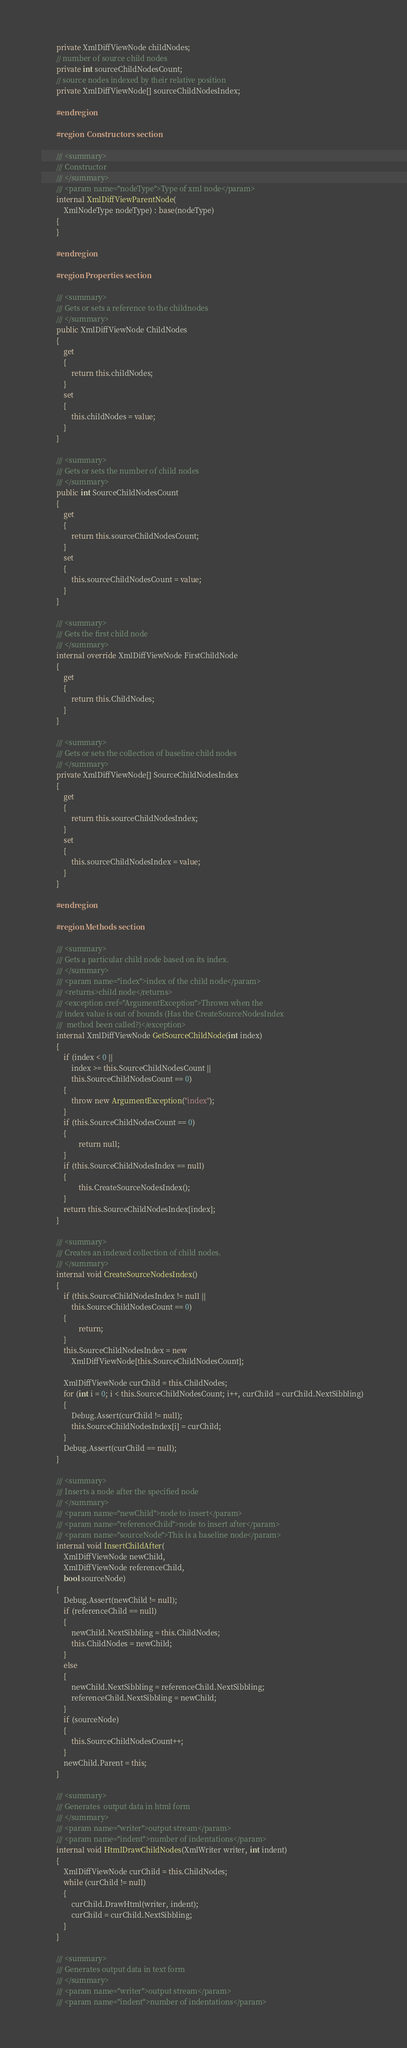<code> <loc_0><loc_0><loc_500><loc_500><_C#_>        private XmlDiffViewNode childNodes;
        // number of source child nodes
        private int sourceChildNodesCount;
        // source nodes indexed by their relative position
        private XmlDiffViewNode[] sourceChildNodesIndex;
        
        #endregion
        
        #region  Constructors section

        /// <summary>
        /// Constructor
        /// </summary>
        /// <param name="nodeType">Type of xml node</param>
        internal XmlDiffViewParentNode(
            XmlNodeType nodeType) : base(nodeType) 
        {
        }
        
        #endregion

        #region Properties section

        /// <summary>
        /// Gets or sets a reference to the childnodes
        /// </summary>
        public XmlDiffViewNode ChildNodes
        {
            get
            {
                return this.childNodes;
            }
            set
            {
                this.childNodes = value;
            }
        }

        /// <summary>
        /// Gets or sets the number of child nodes
        /// </summary>
        public int SourceChildNodesCount
        {
            get
            {
                return this.sourceChildNodesCount;
            }
            set
            {
                this.sourceChildNodesCount = value;
            }
        }

        /// <summary>
        /// Gets the first child node
        /// </summary>
        internal override XmlDiffViewNode FirstChildNode
        { 
            get 
            { 
                return this.ChildNodes; 
            } 
        }

        /// <summary>
        /// Gets or sets the collection of baseline child nodes
        /// </summary>
        private XmlDiffViewNode[] SourceChildNodesIndex
        {
            get
            {
                return this.sourceChildNodesIndex;
            }
            set
            {
                this.sourceChildNodesIndex = value;
            }
        }

        #endregion
        
        #region Methods section

        /// <summary>
        /// Gets a particular child node based on its index.
        /// </summary>
        /// <param name="index">index of the child node</param>
        /// <returns>child node</returns>
        /// <exception cref="ArgumentException">Thrown when the
        /// index value is out of bounds (Has the CreateSourceNodesIndex
        ///  method been called?)</exception>
        internal XmlDiffViewNode GetSourceChildNode(int index) 
        { 
            if (index < 0 || 
                index >= this.SourceChildNodesCount || 
                this.SourceChildNodesCount == 0)
            {
                throw new ArgumentException("index");
            }
            if (this.SourceChildNodesCount == 0)
            {
                    return null;
            }
            if (this.SourceChildNodesIndex == null)
            {
                    this.CreateSourceNodesIndex();
            }
            return this.SourceChildNodesIndex[index];
        }

        /// <summary>
        /// Creates an indexed collection of child nodes.
        /// </summary>
        internal void CreateSourceNodesIndex()
        {
            if (this.SourceChildNodesIndex != null || 
                this.SourceChildNodesCount == 0)
            {
                    return;
            }
            this.SourceChildNodesIndex = new 
                XmlDiffViewNode[this.SourceChildNodesCount];
        
            XmlDiffViewNode curChild = this.ChildNodes;
            for (int i = 0; i < this.SourceChildNodesCount; i++, curChild = curChild.NextSibbling) 
            {
                Debug.Assert(curChild != null);
                this.SourceChildNodesIndex[i] = curChild;
            }
            Debug.Assert(curChild == null);
        }

        /// <summary>
        /// Inserts a node after the specified node
        /// </summary>
        /// <param name="newChild">node to insert</param>
        /// <param name="referenceChild">node to insert after</param>
        /// <param name="sourceNode">This is a baseline node</param>
        internal void InsertChildAfter(
            XmlDiffViewNode newChild, 
            XmlDiffViewNode referenceChild, 
            bool sourceNode) 
        {
            Debug.Assert(newChild != null);
            if (referenceChild == null) 
            {
                newChild.NextSibbling = this.ChildNodes;
                this.ChildNodes = newChild;
            }
            else 
            {
                newChild.NextSibbling = referenceChild.NextSibbling;
                referenceChild.NextSibbling = newChild;
            }
            if (sourceNode)
            {
                this.SourceChildNodesCount++;
            }
            newChild.Parent = this;
        }

        /// <summary>
        /// Generates  output data in html form
        /// </summary>
        /// <param name="writer">output stream</param>
        /// <param name="indent">number of indentations</param>
        internal void HtmlDrawChildNodes(XmlWriter writer, int indent) 
        {
            XmlDiffViewNode curChild = this.ChildNodes;
            while (curChild != null) 
            {
                curChild.DrawHtml(writer, indent);
                curChild = curChild.NextSibbling;
            }
        }

        /// <summary>
        /// Generates output data in text form
        /// </summary>
        /// <param name="writer">output stream</param>
        /// <param name="indent">number of indentations</param></code> 